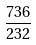Convert formula to latex. <formula><loc_0><loc_0><loc_500><loc_500>\frac { 7 3 6 } { 2 3 2 }</formula> 